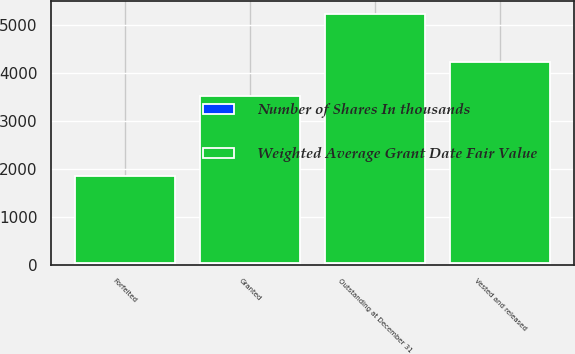<chart> <loc_0><loc_0><loc_500><loc_500><stacked_bar_chart><ecel><fcel>Outstanding at December 31<fcel>Granted<fcel>Vested and released<fcel>Forfeited<nl><fcel>Weighted Average Grant Date Fair Value<fcel>5187<fcel>3467<fcel>4193<fcel>1811<nl><fcel>Number of Shares In thousands<fcel>41.48<fcel>37.07<fcel>23.84<fcel>25.1<nl></chart> 